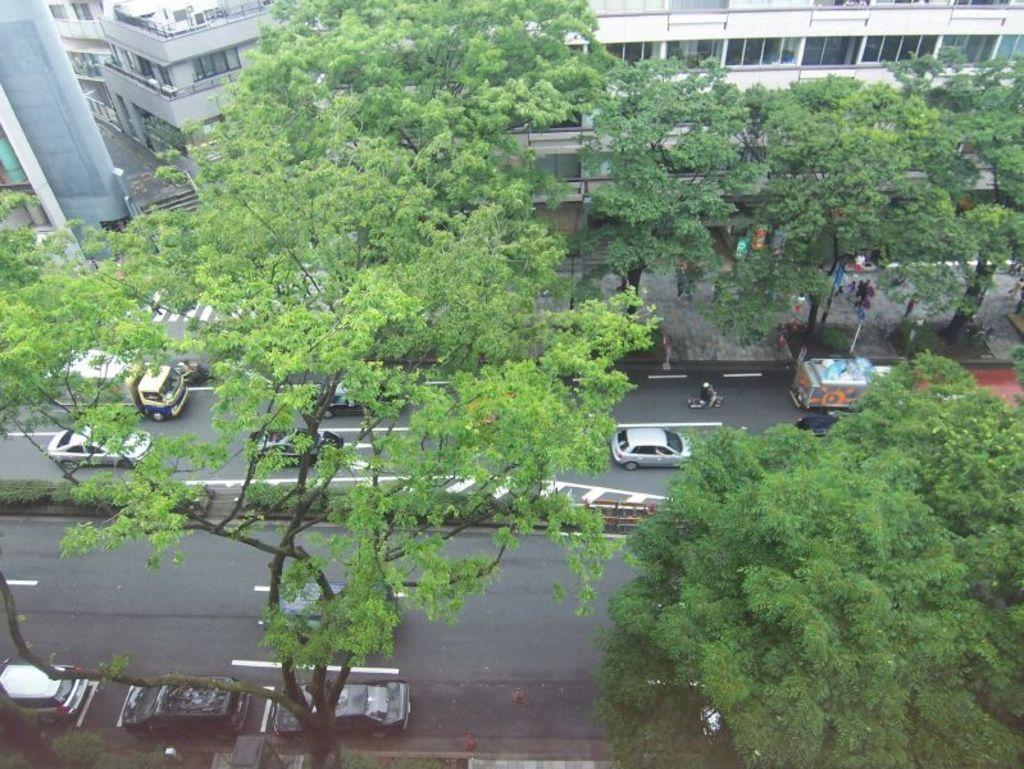What is the main feature of the image? There is a road in the image. What is happening on the road? There are vehicles on the road. What type of vegetation can be seen in the image? There are green trees visible in the image. What type of structures are present in the image? There are buildings in the image. What feature can be seen on the buildings? There are windows on the buildings. Can you see the ocean in the image? No, the ocean is not present in the image. What type of current is visible in the image? There is no current visible in the image, as it does not depict a body of water. 